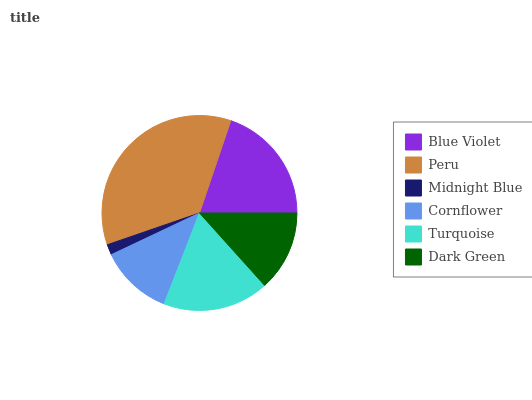Is Midnight Blue the minimum?
Answer yes or no. Yes. Is Peru the maximum?
Answer yes or no. Yes. Is Peru the minimum?
Answer yes or no. No. Is Midnight Blue the maximum?
Answer yes or no. No. Is Peru greater than Midnight Blue?
Answer yes or no. Yes. Is Midnight Blue less than Peru?
Answer yes or no. Yes. Is Midnight Blue greater than Peru?
Answer yes or no. No. Is Peru less than Midnight Blue?
Answer yes or no. No. Is Turquoise the high median?
Answer yes or no. Yes. Is Dark Green the low median?
Answer yes or no. Yes. Is Blue Violet the high median?
Answer yes or no. No. Is Midnight Blue the low median?
Answer yes or no. No. 